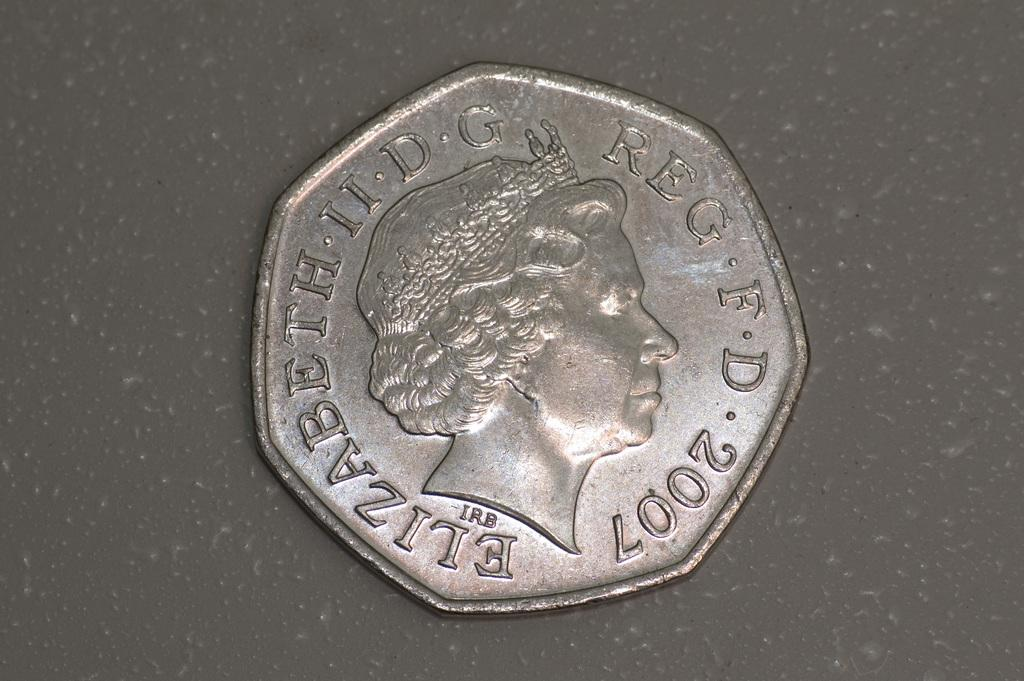<image>
Relay a brief, clear account of the picture shown. Coin will be have one image and it is the 2007 year coin 